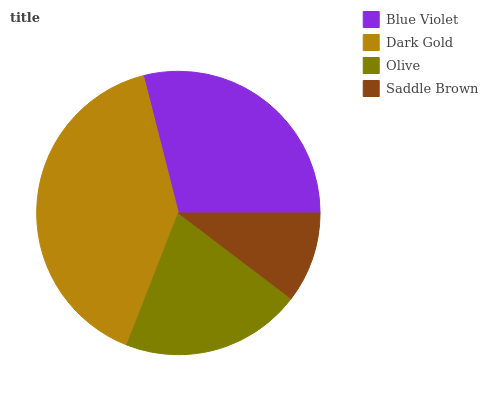Is Saddle Brown the minimum?
Answer yes or no. Yes. Is Dark Gold the maximum?
Answer yes or no. Yes. Is Olive the minimum?
Answer yes or no. No. Is Olive the maximum?
Answer yes or no. No. Is Dark Gold greater than Olive?
Answer yes or no. Yes. Is Olive less than Dark Gold?
Answer yes or no. Yes. Is Olive greater than Dark Gold?
Answer yes or no. No. Is Dark Gold less than Olive?
Answer yes or no. No. Is Blue Violet the high median?
Answer yes or no. Yes. Is Olive the low median?
Answer yes or no. Yes. Is Olive the high median?
Answer yes or no. No. Is Dark Gold the low median?
Answer yes or no. No. 